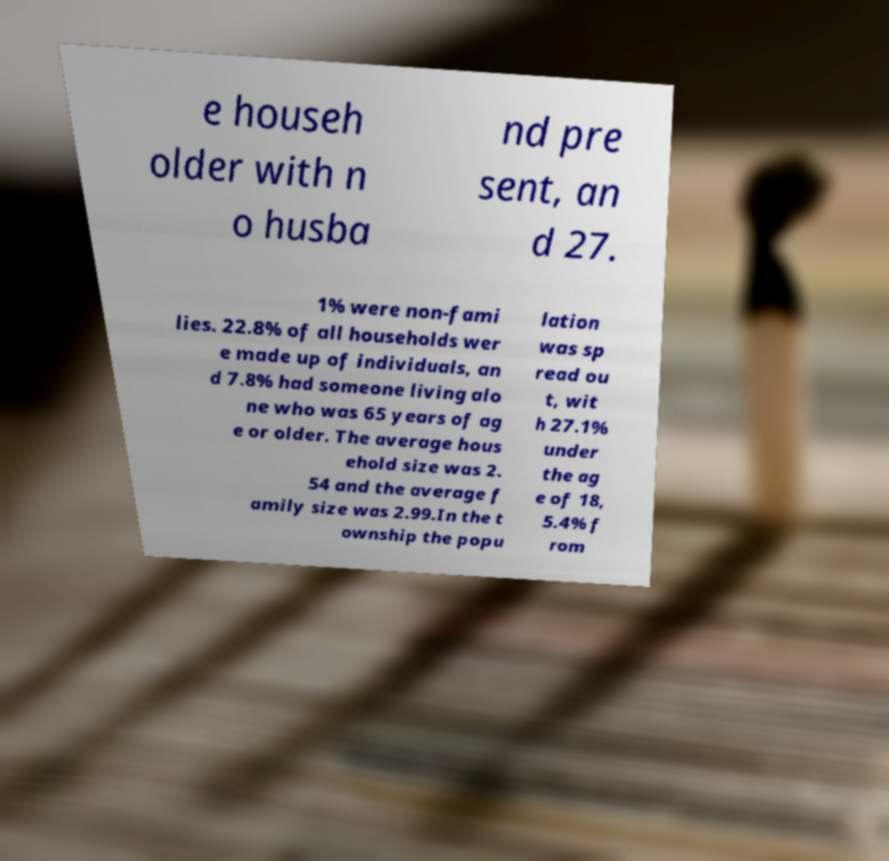Please identify and transcribe the text found in this image. e househ older with n o husba nd pre sent, an d 27. 1% were non-fami lies. 22.8% of all households wer e made up of individuals, an d 7.8% had someone living alo ne who was 65 years of ag e or older. The average hous ehold size was 2. 54 and the average f amily size was 2.99.In the t ownship the popu lation was sp read ou t, wit h 27.1% under the ag e of 18, 5.4% f rom 